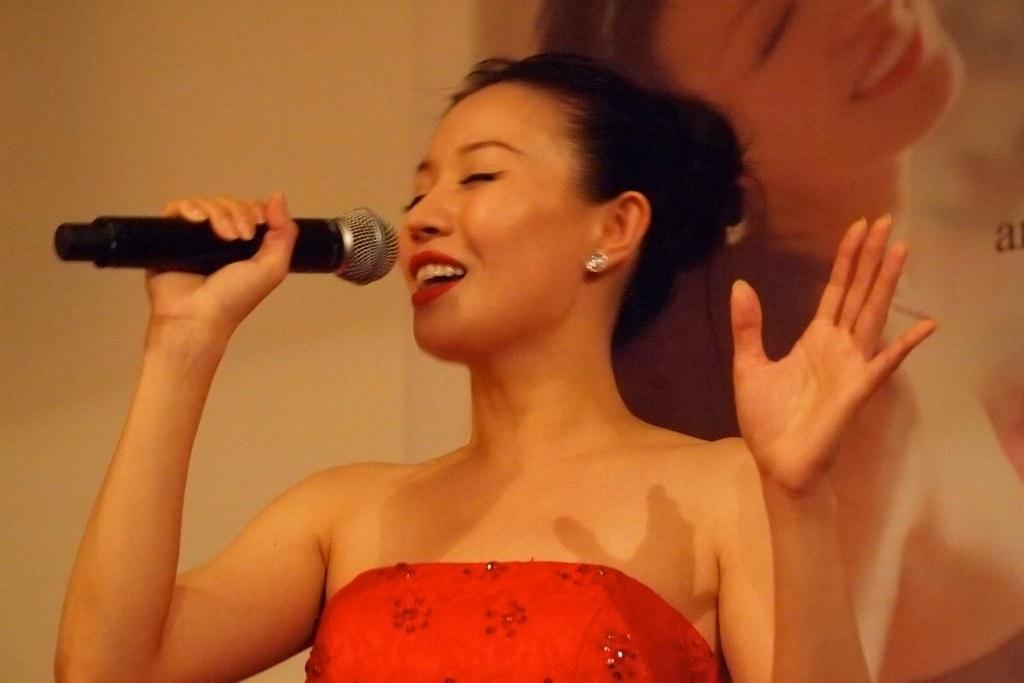Describe this image in one or two sentences. In this image i can see a woman holding a mic and singing a song. She is wearing a red color dress. 